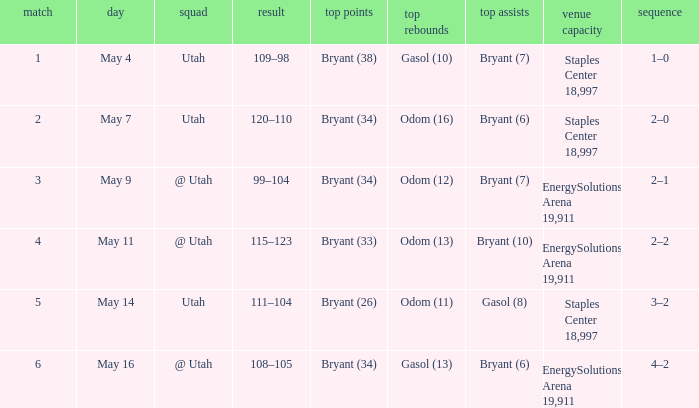What is the Series with a High rebounds with gasol (10)? 1–0. 